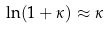Convert formula to latex. <formula><loc_0><loc_0><loc_500><loc_500>\ln ( 1 + \kappa ) \approx \kappa</formula> 